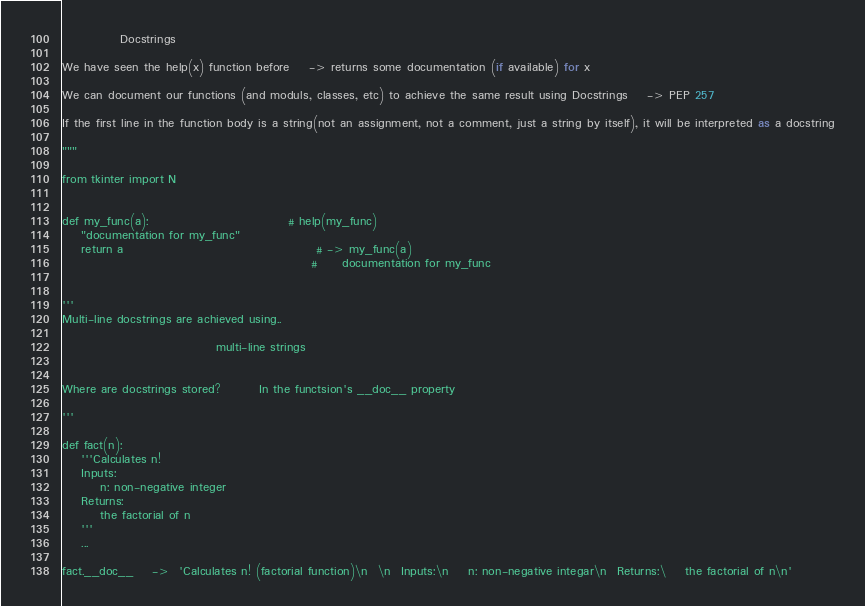Convert code to text. <code><loc_0><loc_0><loc_500><loc_500><_Python_>



            Docstrings

We have seen the help(x) function before    -> returns some documentation (if available) for x

We can document our functions (and moduls, classes, etc) to achieve the same result using Docstrings    -> PEP 257

If the first line in the function body is a string(not an assignment, not a comment, just a string by itself), it will be interpreted as a docstring

"""

from tkinter import N


def my_func(a):                             # help(my_func)
    "documentation for my_func"
    return a                                        # -> my_func(a)
                                                    #     documentation for my_func


'''
Multi-line docstrings are achieved using..

                                multi-line strings


Where are docstrings stored?        In the functsion's __doc__ property

'''

def fact(n):
    '''Calculates n!
    Inputs:
        n: non-negative integer
    Returns:
        the factorial of n
    '''
    ...

fact.__doc__    ->  'Calculates n! (factorial function)\n  \n  Inputs:\n    n: non-negative integar\n  Returns:\    the factorial of n\n'
</code> 